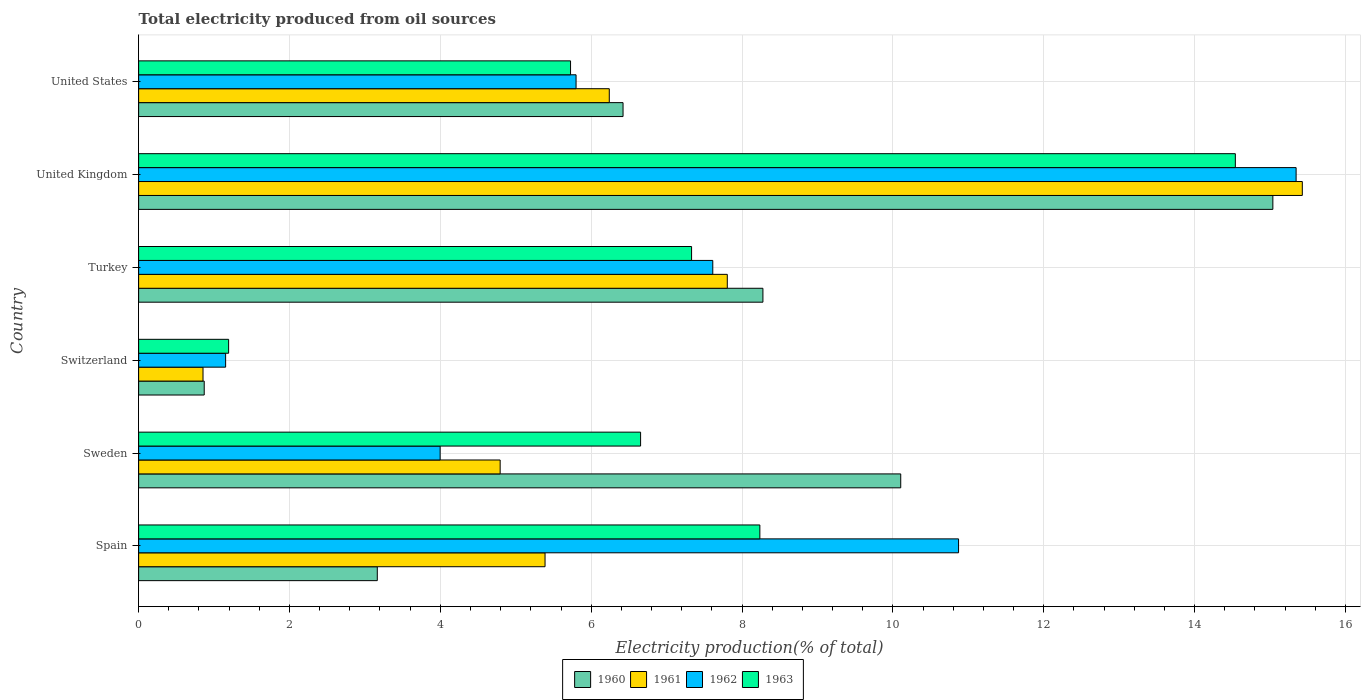How many different coloured bars are there?
Offer a very short reply. 4. Are the number of bars per tick equal to the number of legend labels?
Give a very brief answer. Yes. Are the number of bars on each tick of the Y-axis equal?
Ensure brevity in your answer.  Yes. How many bars are there on the 3rd tick from the top?
Give a very brief answer. 4. How many bars are there on the 5th tick from the bottom?
Make the answer very short. 4. What is the total electricity produced in 1962 in Spain?
Ensure brevity in your answer.  10.87. Across all countries, what is the maximum total electricity produced in 1960?
Provide a short and direct response. 15.04. Across all countries, what is the minimum total electricity produced in 1962?
Offer a very short reply. 1.15. In which country was the total electricity produced in 1962 minimum?
Offer a very short reply. Switzerland. What is the total total electricity produced in 1961 in the graph?
Provide a succinct answer. 40.51. What is the difference between the total electricity produced in 1963 in Turkey and that in United States?
Your response must be concise. 1.6. What is the difference between the total electricity produced in 1962 in Switzerland and the total electricity produced in 1963 in United States?
Keep it short and to the point. -4.57. What is the average total electricity produced in 1961 per country?
Ensure brevity in your answer.  6.75. What is the difference between the total electricity produced in 1963 and total electricity produced in 1962 in Spain?
Offer a terse response. -2.63. In how many countries, is the total electricity produced in 1960 greater than 15.2 %?
Provide a succinct answer. 0. What is the ratio of the total electricity produced in 1962 in Sweden to that in United States?
Provide a succinct answer. 0.69. Is the total electricity produced in 1960 in Turkey less than that in United States?
Provide a succinct answer. No. Is the difference between the total electricity produced in 1963 in Turkey and United States greater than the difference between the total electricity produced in 1962 in Turkey and United States?
Provide a short and direct response. No. What is the difference between the highest and the second highest total electricity produced in 1961?
Offer a terse response. 7.62. What is the difference between the highest and the lowest total electricity produced in 1961?
Provide a succinct answer. 14.57. Is the sum of the total electricity produced in 1963 in Turkey and United States greater than the maximum total electricity produced in 1961 across all countries?
Offer a terse response. No. Is it the case that in every country, the sum of the total electricity produced in 1961 and total electricity produced in 1960 is greater than the sum of total electricity produced in 1962 and total electricity produced in 1963?
Your answer should be compact. No. What does the 3rd bar from the top in Switzerland represents?
Your answer should be compact. 1961. What does the 4th bar from the bottom in Turkey represents?
Provide a short and direct response. 1963. How many bars are there?
Offer a terse response. 24. What is the difference between two consecutive major ticks on the X-axis?
Your answer should be compact. 2. Are the values on the major ticks of X-axis written in scientific E-notation?
Give a very brief answer. No. Does the graph contain any zero values?
Your answer should be compact. No. Where does the legend appear in the graph?
Provide a succinct answer. Bottom center. What is the title of the graph?
Give a very brief answer. Total electricity produced from oil sources. What is the Electricity production(% of total) of 1960 in Spain?
Make the answer very short. 3.16. What is the Electricity production(% of total) in 1961 in Spain?
Your answer should be compact. 5.39. What is the Electricity production(% of total) in 1962 in Spain?
Your answer should be very brief. 10.87. What is the Electricity production(% of total) in 1963 in Spain?
Your response must be concise. 8.24. What is the Electricity production(% of total) in 1960 in Sweden?
Your response must be concise. 10.1. What is the Electricity production(% of total) in 1961 in Sweden?
Provide a short and direct response. 4.79. What is the Electricity production(% of total) of 1962 in Sweden?
Your answer should be very brief. 4. What is the Electricity production(% of total) in 1963 in Sweden?
Your answer should be compact. 6.66. What is the Electricity production(% of total) of 1960 in Switzerland?
Make the answer very short. 0.87. What is the Electricity production(% of total) of 1961 in Switzerland?
Ensure brevity in your answer.  0.85. What is the Electricity production(% of total) of 1962 in Switzerland?
Ensure brevity in your answer.  1.15. What is the Electricity production(% of total) of 1963 in Switzerland?
Your response must be concise. 1.19. What is the Electricity production(% of total) in 1960 in Turkey?
Provide a succinct answer. 8.28. What is the Electricity production(% of total) in 1961 in Turkey?
Offer a very short reply. 7.8. What is the Electricity production(% of total) in 1962 in Turkey?
Your response must be concise. 7.61. What is the Electricity production(% of total) in 1963 in Turkey?
Provide a succinct answer. 7.33. What is the Electricity production(% of total) of 1960 in United Kingdom?
Provide a succinct answer. 15.04. What is the Electricity production(% of total) in 1961 in United Kingdom?
Your answer should be very brief. 15.43. What is the Electricity production(% of total) of 1962 in United Kingdom?
Provide a succinct answer. 15.35. What is the Electricity production(% of total) in 1963 in United Kingdom?
Provide a succinct answer. 14.54. What is the Electricity production(% of total) in 1960 in United States?
Provide a succinct answer. 6.42. What is the Electricity production(% of total) of 1961 in United States?
Give a very brief answer. 6.24. What is the Electricity production(% of total) in 1962 in United States?
Make the answer very short. 5.8. What is the Electricity production(% of total) of 1963 in United States?
Keep it short and to the point. 5.73. Across all countries, what is the maximum Electricity production(% of total) of 1960?
Give a very brief answer. 15.04. Across all countries, what is the maximum Electricity production(% of total) in 1961?
Offer a terse response. 15.43. Across all countries, what is the maximum Electricity production(% of total) in 1962?
Give a very brief answer. 15.35. Across all countries, what is the maximum Electricity production(% of total) in 1963?
Provide a succinct answer. 14.54. Across all countries, what is the minimum Electricity production(% of total) in 1960?
Ensure brevity in your answer.  0.87. Across all countries, what is the minimum Electricity production(% of total) in 1961?
Your response must be concise. 0.85. Across all countries, what is the minimum Electricity production(% of total) in 1962?
Give a very brief answer. 1.15. Across all countries, what is the minimum Electricity production(% of total) in 1963?
Ensure brevity in your answer.  1.19. What is the total Electricity production(% of total) of 1960 in the graph?
Ensure brevity in your answer.  43.88. What is the total Electricity production(% of total) of 1961 in the graph?
Ensure brevity in your answer.  40.51. What is the total Electricity production(% of total) of 1962 in the graph?
Your answer should be very brief. 44.78. What is the total Electricity production(% of total) of 1963 in the graph?
Provide a succinct answer. 43.68. What is the difference between the Electricity production(% of total) of 1960 in Spain and that in Sweden?
Your answer should be very brief. -6.94. What is the difference between the Electricity production(% of total) in 1961 in Spain and that in Sweden?
Ensure brevity in your answer.  0.6. What is the difference between the Electricity production(% of total) of 1962 in Spain and that in Sweden?
Offer a terse response. 6.87. What is the difference between the Electricity production(% of total) in 1963 in Spain and that in Sweden?
Keep it short and to the point. 1.58. What is the difference between the Electricity production(% of total) in 1960 in Spain and that in Switzerland?
Your response must be concise. 2.29. What is the difference between the Electricity production(% of total) in 1961 in Spain and that in Switzerland?
Give a very brief answer. 4.53. What is the difference between the Electricity production(% of total) in 1962 in Spain and that in Switzerland?
Give a very brief answer. 9.72. What is the difference between the Electricity production(% of total) of 1963 in Spain and that in Switzerland?
Your answer should be compact. 7.04. What is the difference between the Electricity production(% of total) of 1960 in Spain and that in Turkey?
Offer a terse response. -5.11. What is the difference between the Electricity production(% of total) of 1961 in Spain and that in Turkey?
Provide a succinct answer. -2.42. What is the difference between the Electricity production(% of total) of 1962 in Spain and that in Turkey?
Give a very brief answer. 3.26. What is the difference between the Electricity production(% of total) of 1963 in Spain and that in Turkey?
Make the answer very short. 0.91. What is the difference between the Electricity production(% of total) in 1960 in Spain and that in United Kingdom?
Give a very brief answer. -11.87. What is the difference between the Electricity production(% of total) in 1961 in Spain and that in United Kingdom?
Keep it short and to the point. -10.04. What is the difference between the Electricity production(% of total) in 1962 in Spain and that in United Kingdom?
Your response must be concise. -4.48. What is the difference between the Electricity production(% of total) of 1963 in Spain and that in United Kingdom?
Your answer should be very brief. -6.3. What is the difference between the Electricity production(% of total) of 1960 in Spain and that in United States?
Your answer should be very brief. -3.26. What is the difference between the Electricity production(% of total) in 1961 in Spain and that in United States?
Ensure brevity in your answer.  -0.85. What is the difference between the Electricity production(% of total) in 1962 in Spain and that in United States?
Offer a terse response. 5.07. What is the difference between the Electricity production(% of total) of 1963 in Spain and that in United States?
Provide a succinct answer. 2.51. What is the difference between the Electricity production(% of total) in 1960 in Sweden and that in Switzerland?
Your response must be concise. 9.23. What is the difference between the Electricity production(% of total) in 1961 in Sweden and that in Switzerland?
Keep it short and to the point. 3.94. What is the difference between the Electricity production(% of total) in 1962 in Sweden and that in Switzerland?
Your response must be concise. 2.84. What is the difference between the Electricity production(% of total) in 1963 in Sweden and that in Switzerland?
Provide a succinct answer. 5.46. What is the difference between the Electricity production(% of total) in 1960 in Sweden and that in Turkey?
Make the answer very short. 1.83. What is the difference between the Electricity production(% of total) in 1961 in Sweden and that in Turkey?
Give a very brief answer. -3.01. What is the difference between the Electricity production(% of total) in 1962 in Sweden and that in Turkey?
Ensure brevity in your answer.  -3.61. What is the difference between the Electricity production(% of total) of 1963 in Sweden and that in Turkey?
Give a very brief answer. -0.68. What is the difference between the Electricity production(% of total) of 1960 in Sweden and that in United Kingdom?
Your answer should be compact. -4.93. What is the difference between the Electricity production(% of total) of 1961 in Sweden and that in United Kingdom?
Offer a very short reply. -10.64. What is the difference between the Electricity production(% of total) in 1962 in Sweden and that in United Kingdom?
Give a very brief answer. -11.35. What is the difference between the Electricity production(% of total) in 1963 in Sweden and that in United Kingdom?
Make the answer very short. -7.89. What is the difference between the Electricity production(% of total) in 1960 in Sweden and that in United States?
Your answer should be compact. 3.68. What is the difference between the Electricity production(% of total) in 1961 in Sweden and that in United States?
Keep it short and to the point. -1.45. What is the difference between the Electricity production(% of total) in 1962 in Sweden and that in United States?
Your answer should be very brief. -1.8. What is the difference between the Electricity production(% of total) of 1963 in Sweden and that in United States?
Provide a short and direct response. 0.93. What is the difference between the Electricity production(% of total) of 1960 in Switzerland and that in Turkey?
Your answer should be compact. -7.41. What is the difference between the Electricity production(% of total) of 1961 in Switzerland and that in Turkey?
Offer a terse response. -6.95. What is the difference between the Electricity production(% of total) in 1962 in Switzerland and that in Turkey?
Your answer should be compact. -6.46. What is the difference between the Electricity production(% of total) in 1963 in Switzerland and that in Turkey?
Provide a succinct answer. -6.14. What is the difference between the Electricity production(% of total) in 1960 in Switzerland and that in United Kingdom?
Provide a short and direct response. -14.17. What is the difference between the Electricity production(% of total) of 1961 in Switzerland and that in United Kingdom?
Your answer should be very brief. -14.57. What is the difference between the Electricity production(% of total) in 1962 in Switzerland and that in United Kingdom?
Give a very brief answer. -14.19. What is the difference between the Electricity production(% of total) in 1963 in Switzerland and that in United Kingdom?
Offer a very short reply. -13.35. What is the difference between the Electricity production(% of total) in 1960 in Switzerland and that in United States?
Keep it short and to the point. -5.55. What is the difference between the Electricity production(% of total) in 1961 in Switzerland and that in United States?
Provide a succinct answer. -5.39. What is the difference between the Electricity production(% of total) of 1962 in Switzerland and that in United States?
Provide a succinct answer. -4.65. What is the difference between the Electricity production(% of total) in 1963 in Switzerland and that in United States?
Offer a terse response. -4.53. What is the difference between the Electricity production(% of total) of 1960 in Turkey and that in United Kingdom?
Offer a very short reply. -6.76. What is the difference between the Electricity production(% of total) of 1961 in Turkey and that in United Kingdom?
Your response must be concise. -7.62. What is the difference between the Electricity production(% of total) of 1962 in Turkey and that in United Kingdom?
Provide a succinct answer. -7.73. What is the difference between the Electricity production(% of total) of 1963 in Turkey and that in United Kingdom?
Give a very brief answer. -7.21. What is the difference between the Electricity production(% of total) in 1960 in Turkey and that in United States?
Provide a succinct answer. 1.85. What is the difference between the Electricity production(% of total) of 1961 in Turkey and that in United States?
Your answer should be compact. 1.56. What is the difference between the Electricity production(% of total) of 1962 in Turkey and that in United States?
Provide a succinct answer. 1.81. What is the difference between the Electricity production(% of total) in 1963 in Turkey and that in United States?
Make the answer very short. 1.6. What is the difference between the Electricity production(% of total) in 1960 in United Kingdom and that in United States?
Keep it short and to the point. 8.62. What is the difference between the Electricity production(% of total) of 1961 in United Kingdom and that in United States?
Your answer should be compact. 9.19. What is the difference between the Electricity production(% of total) of 1962 in United Kingdom and that in United States?
Offer a very short reply. 9.55. What is the difference between the Electricity production(% of total) of 1963 in United Kingdom and that in United States?
Your answer should be compact. 8.81. What is the difference between the Electricity production(% of total) in 1960 in Spain and the Electricity production(% of total) in 1961 in Sweden?
Offer a terse response. -1.63. What is the difference between the Electricity production(% of total) in 1960 in Spain and the Electricity production(% of total) in 1963 in Sweden?
Give a very brief answer. -3.49. What is the difference between the Electricity production(% of total) of 1961 in Spain and the Electricity production(% of total) of 1962 in Sweden?
Offer a very short reply. 1.39. What is the difference between the Electricity production(% of total) of 1961 in Spain and the Electricity production(% of total) of 1963 in Sweden?
Give a very brief answer. -1.27. What is the difference between the Electricity production(% of total) of 1962 in Spain and the Electricity production(% of total) of 1963 in Sweden?
Give a very brief answer. 4.22. What is the difference between the Electricity production(% of total) of 1960 in Spain and the Electricity production(% of total) of 1961 in Switzerland?
Your response must be concise. 2.31. What is the difference between the Electricity production(% of total) in 1960 in Spain and the Electricity production(% of total) in 1962 in Switzerland?
Offer a terse response. 2.01. What is the difference between the Electricity production(% of total) in 1960 in Spain and the Electricity production(% of total) in 1963 in Switzerland?
Your response must be concise. 1.97. What is the difference between the Electricity production(% of total) in 1961 in Spain and the Electricity production(% of total) in 1962 in Switzerland?
Offer a terse response. 4.24. What is the difference between the Electricity production(% of total) of 1961 in Spain and the Electricity production(% of total) of 1963 in Switzerland?
Keep it short and to the point. 4.2. What is the difference between the Electricity production(% of total) in 1962 in Spain and the Electricity production(% of total) in 1963 in Switzerland?
Offer a very short reply. 9.68. What is the difference between the Electricity production(% of total) of 1960 in Spain and the Electricity production(% of total) of 1961 in Turkey?
Provide a short and direct response. -4.64. What is the difference between the Electricity production(% of total) of 1960 in Spain and the Electricity production(% of total) of 1962 in Turkey?
Give a very brief answer. -4.45. What is the difference between the Electricity production(% of total) in 1960 in Spain and the Electricity production(% of total) in 1963 in Turkey?
Keep it short and to the point. -4.17. What is the difference between the Electricity production(% of total) of 1961 in Spain and the Electricity production(% of total) of 1962 in Turkey?
Provide a short and direct response. -2.22. What is the difference between the Electricity production(% of total) in 1961 in Spain and the Electricity production(% of total) in 1963 in Turkey?
Your answer should be very brief. -1.94. What is the difference between the Electricity production(% of total) in 1962 in Spain and the Electricity production(% of total) in 1963 in Turkey?
Provide a succinct answer. 3.54. What is the difference between the Electricity production(% of total) of 1960 in Spain and the Electricity production(% of total) of 1961 in United Kingdom?
Keep it short and to the point. -12.26. What is the difference between the Electricity production(% of total) of 1960 in Spain and the Electricity production(% of total) of 1962 in United Kingdom?
Your answer should be very brief. -12.18. What is the difference between the Electricity production(% of total) of 1960 in Spain and the Electricity production(% of total) of 1963 in United Kingdom?
Offer a terse response. -11.38. What is the difference between the Electricity production(% of total) of 1961 in Spain and the Electricity production(% of total) of 1962 in United Kingdom?
Provide a short and direct response. -9.96. What is the difference between the Electricity production(% of total) in 1961 in Spain and the Electricity production(% of total) in 1963 in United Kingdom?
Ensure brevity in your answer.  -9.15. What is the difference between the Electricity production(% of total) in 1962 in Spain and the Electricity production(% of total) in 1963 in United Kingdom?
Provide a short and direct response. -3.67. What is the difference between the Electricity production(% of total) in 1960 in Spain and the Electricity production(% of total) in 1961 in United States?
Your response must be concise. -3.08. What is the difference between the Electricity production(% of total) of 1960 in Spain and the Electricity production(% of total) of 1962 in United States?
Your answer should be compact. -2.64. What is the difference between the Electricity production(% of total) in 1960 in Spain and the Electricity production(% of total) in 1963 in United States?
Give a very brief answer. -2.56. What is the difference between the Electricity production(% of total) of 1961 in Spain and the Electricity production(% of total) of 1962 in United States?
Your answer should be compact. -0.41. What is the difference between the Electricity production(% of total) of 1961 in Spain and the Electricity production(% of total) of 1963 in United States?
Your response must be concise. -0.34. What is the difference between the Electricity production(% of total) of 1962 in Spain and the Electricity production(% of total) of 1963 in United States?
Ensure brevity in your answer.  5.14. What is the difference between the Electricity production(% of total) in 1960 in Sweden and the Electricity production(% of total) in 1961 in Switzerland?
Provide a succinct answer. 9.25. What is the difference between the Electricity production(% of total) in 1960 in Sweden and the Electricity production(% of total) in 1962 in Switzerland?
Offer a very short reply. 8.95. What is the difference between the Electricity production(% of total) in 1960 in Sweden and the Electricity production(% of total) in 1963 in Switzerland?
Keep it short and to the point. 8.91. What is the difference between the Electricity production(% of total) of 1961 in Sweden and the Electricity production(% of total) of 1962 in Switzerland?
Your response must be concise. 3.64. What is the difference between the Electricity production(% of total) of 1962 in Sweden and the Electricity production(% of total) of 1963 in Switzerland?
Provide a short and direct response. 2.8. What is the difference between the Electricity production(% of total) in 1960 in Sweden and the Electricity production(% of total) in 1961 in Turkey?
Your response must be concise. 2.3. What is the difference between the Electricity production(% of total) of 1960 in Sweden and the Electricity production(% of total) of 1962 in Turkey?
Your answer should be very brief. 2.49. What is the difference between the Electricity production(% of total) of 1960 in Sweden and the Electricity production(% of total) of 1963 in Turkey?
Your answer should be very brief. 2.77. What is the difference between the Electricity production(% of total) in 1961 in Sweden and the Electricity production(% of total) in 1962 in Turkey?
Keep it short and to the point. -2.82. What is the difference between the Electricity production(% of total) of 1961 in Sweden and the Electricity production(% of total) of 1963 in Turkey?
Provide a succinct answer. -2.54. What is the difference between the Electricity production(% of total) in 1962 in Sweden and the Electricity production(% of total) in 1963 in Turkey?
Your response must be concise. -3.33. What is the difference between the Electricity production(% of total) in 1960 in Sweden and the Electricity production(% of total) in 1961 in United Kingdom?
Offer a very short reply. -5.32. What is the difference between the Electricity production(% of total) of 1960 in Sweden and the Electricity production(% of total) of 1962 in United Kingdom?
Offer a very short reply. -5.24. What is the difference between the Electricity production(% of total) in 1960 in Sweden and the Electricity production(% of total) in 1963 in United Kingdom?
Provide a short and direct response. -4.44. What is the difference between the Electricity production(% of total) in 1961 in Sweden and the Electricity production(% of total) in 1962 in United Kingdom?
Keep it short and to the point. -10.55. What is the difference between the Electricity production(% of total) of 1961 in Sweden and the Electricity production(% of total) of 1963 in United Kingdom?
Keep it short and to the point. -9.75. What is the difference between the Electricity production(% of total) in 1962 in Sweden and the Electricity production(% of total) in 1963 in United Kingdom?
Your answer should be very brief. -10.54. What is the difference between the Electricity production(% of total) in 1960 in Sweden and the Electricity production(% of total) in 1961 in United States?
Offer a terse response. 3.86. What is the difference between the Electricity production(% of total) in 1960 in Sweden and the Electricity production(% of total) in 1962 in United States?
Make the answer very short. 4.3. What is the difference between the Electricity production(% of total) of 1960 in Sweden and the Electricity production(% of total) of 1963 in United States?
Your answer should be very brief. 4.38. What is the difference between the Electricity production(% of total) of 1961 in Sweden and the Electricity production(% of total) of 1962 in United States?
Make the answer very short. -1.01. What is the difference between the Electricity production(% of total) in 1961 in Sweden and the Electricity production(% of total) in 1963 in United States?
Provide a short and direct response. -0.93. What is the difference between the Electricity production(% of total) of 1962 in Sweden and the Electricity production(% of total) of 1963 in United States?
Make the answer very short. -1.73. What is the difference between the Electricity production(% of total) in 1960 in Switzerland and the Electricity production(% of total) in 1961 in Turkey?
Your response must be concise. -6.94. What is the difference between the Electricity production(% of total) in 1960 in Switzerland and the Electricity production(% of total) in 1962 in Turkey?
Ensure brevity in your answer.  -6.74. What is the difference between the Electricity production(% of total) in 1960 in Switzerland and the Electricity production(% of total) in 1963 in Turkey?
Ensure brevity in your answer.  -6.46. What is the difference between the Electricity production(% of total) in 1961 in Switzerland and the Electricity production(% of total) in 1962 in Turkey?
Your response must be concise. -6.76. What is the difference between the Electricity production(% of total) in 1961 in Switzerland and the Electricity production(% of total) in 1963 in Turkey?
Ensure brevity in your answer.  -6.48. What is the difference between the Electricity production(% of total) of 1962 in Switzerland and the Electricity production(% of total) of 1963 in Turkey?
Your answer should be compact. -6.18. What is the difference between the Electricity production(% of total) in 1960 in Switzerland and the Electricity production(% of total) in 1961 in United Kingdom?
Your answer should be compact. -14.56. What is the difference between the Electricity production(% of total) of 1960 in Switzerland and the Electricity production(% of total) of 1962 in United Kingdom?
Provide a short and direct response. -14.48. What is the difference between the Electricity production(% of total) of 1960 in Switzerland and the Electricity production(% of total) of 1963 in United Kingdom?
Your answer should be very brief. -13.67. What is the difference between the Electricity production(% of total) of 1961 in Switzerland and the Electricity production(% of total) of 1962 in United Kingdom?
Offer a terse response. -14.49. What is the difference between the Electricity production(% of total) of 1961 in Switzerland and the Electricity production(% of total) of 1963 in United Kingdom?
Your answer should be very brief. -13.69. What is the difference between the Electricity production(% of total) in 1962 in Switzerland and the Electricity production(% of total) in 1963 in United Kingdom?
Provide a succinct answer. -13.39. What is the difference between the Electricity production(% of total) of 1960 in Switzerland and the Electricity production(% of total) of 1961 in United States?
Your answer should be compact. -5.37. What is the difference between the Electricity production(% of total) of 1960 in Switzerland and the Electricity production(% of total) of 1962 in United States?
Ensure brevity in your answer.  -4.93. What is the difference between the Electricity production(% of total) of 1960 in Switzerland and the Electricity production(% of total) of 1963 in United States?
Provide a short and direct response. -4.86. What is the difference between the Electricity production(% of total) of 1961 in Switzerland and the Electricity production(% of total) of 1962 in United States?
Provide a short and direct response. -4.95. What is the difference between the Electricity production(% of total) in 1961 in Switzerland and the Electricity production(% of total) in 1963 in United States?
Ensure brevity in your answer.  -4.87. What is the difference between the Electricity production(% of total) of 1962 in Switzerland and the Electricity production(% of total) of 1963 in United States?
Ensure brevity in your answer.  -4.57. What is the difference between the Electricity production(% of total) in 1960 in Turkey and the Electricity production(% of total) in 1961 in United Kingdom?
Your response must be concise. -7.15. What is the difference between the Electricity production(% of total) of 1960 in Turkey and the Electricity production(% of total) of 1962 in United Kingdom?
Provide a succinct answer. -7.07. What is the difference between the Electricity production(% of total) of 1960 in Turkey and the Electricity production(% of total) of 1963 in United Kingdom?
Offer a terse response. -6.26. What is the difference between the Electricity production(% of total) of 1961 in Turkey and the Electricity production(% of total) of 1962 in United Kingdom?
Your response must be concise. -7.54. What is the difference between the Electricity production(% of total) of 1961 in Turkey and the Electricity production(% of total) of 1963 in United Kingdom?
Provide a short and direct response. -6.74. What is the difference between the Electricity production(% of total) in 1962 in Turkey and the Electricity production(% of total) in 1963 in United Kingdom?
Give a very brief answer. -6.93. What is the difference between the Electricity production(% of total) in 1960 in Turkey and the Electricity production(% of total) in 1961 in United States?
Give a very brief answer. 2.04. What is the difference between the Electricity production(% of total) in 1960 in Turkey and the Electricity production(% of total) in 1962 in United States?
Keep it short and to the point. 2.48. What is the difference between the Electricity production(% of total) in 1960 in Turkey and the Electricity production(% of total) in 1963 in United States?
Your response must be concise. 2.55. What is the difference between the Electricity production(% of total) of 1961 in Turkey and the Electricity production(% of total) of 1962 in United States?
Your response must be concise. 2.01. What is the difference between the Electricity production(% of total) in 1961 in Turkey and the Electricity production(% of total) in 1963 in United States?
Make the answer very short. 2.08. What is the difference between the Electricity production(% of total) in 1962 in Turkey and the Electricity production(% of total) in 1963 in United States?
Offer a terse response. 1.89. What is the difference between the Electricity production(% of total) of 1960 in United Kingdom and the Electricity production(% of total) of 1961 in United States?
Provide a succinct answer. 8.8. What is the difference between the Electricity production(% of total) of 1960 in United Kingdom and the Electricity production(% of total) of 1962 in United States?
Provide a succinct answer. 9.24. What is the difference between the Electricity production(% of total) in 1960 in United Kingdom and the Electricity production(% of total) in 1963 in United States?
Your answer should be very brief. 9.31. What is the difference between the Electricity production(% of total) in 1961 in United Kingdom and the Electricity production(% of total) in 1962 in United States?
Give a very brief answer. 9.63. What is the difference between the Electricity production(% of total) in 1961 in United Kingdom and the Electricity production(% of total) in 1963 in United States?
Make the answer very short. 9.7. What is the difference between the Electricity production(% of total) of 1962 in United Kingdom and the Electricity production(% of total) of 1963 in United States?
Keep it short and to the point. 9.62. What is the average Electricity production(% of total) of 1960 per country?
Your answer should be compact. 7.31. What is the average Electricity production(% of total) of 1961 per country?
Provide a short and direct response. 6.75. What is the average Electricity production(% of total) of 1962 per country?
Provide a short and direct response. 7.46. What is the average Electricity production(% of total) in 1963 per country?
Ensure brevity in your answer.  7.28. What is the difference between the Electricity production(% of total) in 1960 and Electricity production(% of total) in 1961 in Spain?
Offer a very short reply. -2.22. What is the difference between the Electricity production(% of total) of 1960 and Electricity production(% of total) of 1962 in Spain?
Provide a succinct answer. -7.71. What is the difference between the Electricity production(% of total) of 1960 and Electricity production(% of total) of 1963 in Spain?
Offer a very short reply. -5.07. What is the difference between the Electricity production(% of total) in 1961 and Electricity production(% of total) in 1962 in Spain?
Your response must be concise. -5.48. What is the difference between the Electricity production(% of total) of 1961 and Electricity production(% of total) of 1963 in Spain?
Make the answer very short. -2.85. What is the difference between the Electricity production(% of total) in 1962 and Electricity production(% of total) in 1963 in Spain?
Make the answer very short. 2.63. What is the difference between the Electricity production(% of total) of 1960 and Electricity production(% of total) of 1961 in Sweden?
Your answer should be very brief. 5.31. What is the difference between the Electricity production(% of total) in 1960 and Electricity production(% of total) in 1962 in Sweden?
Provide a succinct answer. 6.11. What is the difference between the Electricity production(% of total) in 1960 and Electricity production(% of total) in 1963 in Sweden?
Keep it short and to the point. 3.45. What is the difference between the Electricity production(% of total) in 1961 and Electricity production(% of total) in 1962 in Sweden?
Make the answer very short. 0.8. What is the difference between the Electricity production(% of total) in 1961 and Electricity production(% of total) in 1963 in Sweden?
Keep it short and to the point. -1.86. What is the difference between the Electricity production(% of total) in 1962 and Electricity production(% of total) in 1963 in Sweden?
Your answer should be very brief. -2.66. What is the difference between the Electricity production(% of total) of 1960 and Electricity production(% of total) of 1961 in Switzerland?
Give a very brief answer. 0.02. What is the difference between the Electricity production(% of total) of 1960 and Electricity production(% of total) of 1962 in Switzerland?
Offer a very short reply. -0.28. What is the difference between the Electricity production(% of total) of 1960 and Electricity production(% of total) of 1963 in Switzerland?
Your response must be concise. -0.32. What is the difference between the Electricity production(% of total) of 1961 and Electricity production(% of total) of 1962 in Switzerland?
Provide a short and direct response. -0.3. What is the difference between the Electricity production(% of total) in 1961 and Electricity production(% of total) in 1963 in Switzerland?
Ensure brevity in your answer.  -0.34. What is the difference between the Electricity production(% of total) in 1962 and Electricity production(% of total) in 1963 in Switzerland?
Your answer should be compact. -0.04. What is the difference between the Electricity production(% of total) in 1960 and Electricity production(% of total) in 1961 in Turkey?
Offer a terse response. 0.47. What is the difference between the Electricity production(% of total) in 1960 and Electricity production(% of total) in 1962 in Turkey?
Your answer should be very brief. 0.66. What is the difference between the Electricity production(% of total) of 1960 and Electricity production(% of total) of 1963 in Turkey?
Your answer should be very brief. 0.95. What is the difference between the Electricity production(% of total) of 1961 and Electricity production(% of total) of 1962 in Turkey?
Your answer should be very brief. 0.19. What is the difference between the Electricity production(% of total) in 1961 and Electricity production(% of total) in 1963 in Turkey?
Offer a very short reply. 0.47. What is the difference between the Electricity production(% of total) of 1962 and Electricity production(% of total) of 1963 in Turkey?
Your answer should be very brief. 0.28. What is the difference between the Electricity production(% of total) of 1960 and Electricity production(% of total) of 1961 in United Kingdom?
Make the answer very short. -0.39. What is the difference between the Electricity production(% of total) of 1960 and Electricity production(% of total) of 1962 in United Kingdom?
Provide a succinct answer. -0.31. What is the difference between the Electricity production(% of total) of 1960 and Electricity production(% of total) of 1963 in United Kingdom?
Offer a very short reply. 0.5. What is the difference between the Electricity production(% of total) in 1961 and Electricity production(% of total) in 1962 in United Kingdom?
Your answer should be very brief. 0.08. What is the difference between the Electricity production(% of total) of 1961 and Electricity production(% of total) of 1963 in United Kingdom?
Make the answer very short. 0.89. What is the difference between the Electricity production(% of total) of 1962 and Electricity production(% of total) of 1963 in United Kingdom?
Your answer should be compact. 0.81. What is the difference between the Electricity production(% of total) of 1960 and Electricity production(% of total) of 1961 in United States?
Ensure brevity in your answer.  0.18. What is the difference between the Electricity production(% of total) in 1960 and Electricity production(% of total) in 1962 in United States?
Offer a terse response. 0.62. What is the difference between the Electricity production(% of total) of 1960 and Electricity production(% of total) of 1963 in United States?
Your answer should be compact. 0.7. What is the difference between the Electricity production(% of total) of 1961 and Electricity production(% of total) of 1962 in United States?
Your answer should be very brief. 0.44. What is the difference between the Electricity production(% of total) in 1961 and Electricity production(% of total) in 1963 in United States?
Make the answer very short. 0.51. What is the difference between the Electricity production(% of total) of 1962 and Electricity production(% of total) of 1963 in United States?
Your response must be concise. 0.07. What is the ratio of the Electricity production(% of total) of 1960 in Spain to that in Sweden?
Keep it short and to the point. 0.31. What is the ratio of the Electricity production(% of total) of 1961 in Spain to that in Sweden?
Give a very brief answer. 1.12. What is the ratio of the Electricity production(% of total) in 1962 in Spain to that in Sweden?
Give a very brief answer. 2.72. What is the ratio of the Electricity production(% of total) of 1963 in Spain to that in Sweden?
Keep it short and to the point. 1.24. What is the ratio of the Electricity production(% of total) of 1960 in Spain to that in Switzerland?
Provide a succinct answer. 3.64. What is the ratio of the Electricity production(% of total) in 1961 in Spain to that in Switzerland?
Give a very brief answer. 6.31. What is the ratio of the Electricity production(% of total) in 1962 in Spain to that in Switzerland?
Make the answer very short. 9.43. What is the ratio of the Electricity production(% of total) of 1963 in Spain to that in Switzerland?
Your response must be concise. 6.9. What is the ratio of the Electricity production(% of total) of 1960 in Spain to that in Turkey?
Provide a short and direct response. 0.38. What is the ratio of the Electricity production(% of total) in 1961 in Spain to that in Turkey?
Keep it short and to the point. 0.69. What is the ratio of the Electricity production(% of total) of 1962 in Spain to that in Turkey?
Your answer should be compact. 1.43. What is the ratio of the Electricity production(% of total) of 1963 in Spain to that in Turkey?
Ensure brevity in your answer.  1.12. What is the ratio of the Electricity production(% of total) of 1960 in Spain to that in United Kingdom?
Give a very brief answer. 0.21. What is the ratio of the Electricity production(% of total) in 1961 in Spain to that in United Kingdom?
Give a very brief answer. 0.35. What is the ratio of the Electricity production(% of total) in 1962 in Spain to that in United Kingdom?
Your answer should be very brief. 0.71. What is the ratio of the Electricity production(% of total) of 1963 in Spain to that in United Kingdom?
Offer a very short reply. 0.57. What is the ratio of the Electricity production(% of total) in 1960 in Spain to that in United States?
Provide a succinct answer. 0.49. What is the ratio of the Electricity production(% of total) of 1961 in Spain to that in United States?
Ensure brevity in your answer.  0.86. What is the ratio of the Electricity production(% of total) of 1962 in Spain to that in United States?
Your response must be concise. 1.87. What is the ratio of the Electricity production(% of total) in 1963 in Spain to that in United States?
Give a very brief answer. 1.44. What is the ratio of the Electricity production(% of total) of 1960 in Sweden to that in Switzerland?
Offer a terse response. 11.62. What is the ratio of the Electricity production(% of total) in 1961 in Sweden to that in Switzerland?
Ensure brevity in your answer.  5.62. What is the ratio of the Electricity production(% of total) in 1962 in Sweden to that in Switzerland?
Make the answer very short. 3.47. What is the ratio of the Electricity production(% of total) of 1963 in Sweden to that in Switzerland?
Provide a succinct answer. 5.58. What is the ratio of the Electricity production(% of total) of 1960 in Sweden to that in Turkey?
Ensure brevity in your answer.  1.22. What is the ratio of the Electricity production(% of total) of 1961 in Sweden to that in Turkey?
Provide a succinct answer. 0.61. What is the ratio of the Electricity production(% of total) in 1962 in Sweden to that in Turkey?
Ensure brevity in your answer.  0.53. What is the ratio of the Electricity production(% of total) of 1963 in Sweden to that in Turkey?
Make the answer very short. 0.91. What is the ratio of the Electricity production(% of total) in 1960 in Sweden to that in United Kingdom?
Ensure brevity in your answer.  0.67. What is the ratio of the Electricity production(% of total) of 1961 in Sweden to that in United Kingdom?
Keep it short and to the point. 0.31. What is the ratio of the Electricity production(% of total) of 1962 in Sweden to that in United Kingdom?
Your response must be concise. 0.26. What is the ratio of the Electricity production(% of total) of 1963 in Sweden to that in United Kingdom?
Provide a succinct answer. 0.46. What is the ratio of the Electricity production(% of total) in 1960 in Sweden to that in United States?
Offer a terse response. 1.57. What is the ratio of the Electricity production(% of total) of 1961 in Sweden to that in United States?
Your answer should be very brief. 0.77. What is the ratio of the Electricity production(% of total) in 1962 in Sweden to that in United States?
Offer a very short reply. 0.69. What is the ratio of the Electricity production(% of total) in 1963 in Sweden to that in United States?
Make the answer very short. 1.16. What is the ratio of the Electricity production(% of total) of 1960 in Switzerland to that in Turkey?
Your answer should be very brief. 0.11. What is the ratio of the Electricity production(% of total) in 1961 in Switzerland to that in Turkey?
Your response must be concise. 0.11. What is the ratio of the Electricity production(% of total) of 1962 in Switzerland to that in Turkey?
Make the answer very short. 0.15. What is the ratio of the Electricity production(% of total) in 1963 in Switzerland to that in Turkey?
Ensure brevity in your answer.  0.16. What is the ratio of the Electricity production(% of total) in 1960 in Switzerland to that in United Kingdom?
Give a very brief answer. 0.06. What is the ratio of the Electricity production(% of total) in 1961 in Switzerland to that in United Kingdom?
Your response must be concise. 0.06. What is the ratio of the Electricity production(% of total) of 1962 in Switzerland to that in United Kingdom?
Offer a terse response. 0.08. What is the ratio of the Electricity production(% of total) in 1963 in Switzerland to that in United Kingdom?
Your response must be concise. 0.08. What is the ratio of the Electricity production(% of total) in 1960 in Switzerland to that in United States?
Your response must be concise. 0.14. What is the ratio of the Electricity production(% of total) of 1961 in Switzerland to that in United States?
Your answer should be compact. 0.14. What is the ratio of the Electricity production(% of total) in 1962 in Switzerland to that in United States?
Offer a very short reply. 0.2. What is the ratio of the Electricity production(% of total) in 1963 in Switzerland to that in United States?
Offer a terse response. 0.21. What is the ratio of the Electricity production(% of total) of 1960 in Turkey to that in United Kingdom?
Your answer should be very brief. 0.55. What is the ratio of the Electricity production(% of total) of 1961 in Turkey to that in United Kingdom?
Your response must be concise. 0.51. What is the ratio of the Electricity production(% of total) of 1962 in Turkey to that in United Kingdom?
Your answer should be very brief. 0.5. What is the ratio of the Electricity production(% of total) of 1963 in Turkey to that in United Kingdom?
Your answer should be compact. 0.5. What is the ratio of the Electricity production(% of total) in 1960 in Turkey to that in United States?
Offer a terse response. 1.29. What is the ratio of the Electricity production(% of total) in 1961 in Turkey to that in United States?
Offer a terse response. 1.25. What is the ratio of the Electricity production(% of total) in 1962 in Turkey to that in United States?
Offer a very short reply. 1.31. What is the ratio of the Electricity production(% of total) in 1963 in Turkey to that in United States?
Offer a very short reply. 1.28. What is the ratio of the Electricity production(% of total) of 1960 in United Kingdom to that in United States?
Your response must be concise. 2.34. What is the ratio of the Electricity production(% of total) of 1961 in United Kingdom to that in United States?
Your response must be concise. 2.47. What is the ratio of the Electricity production(% of total) in 1962 in United Kingdom to that in United States?
Make the answer very short. 2.65. What is the ratio of the Electricity production(% of total) in 1963 in United Kingdom to that in United States?
Keep it short and to the point. 2.54. What is the difference between the highest and the second highest Electricity production(% of total) of 1960?
Offer a terse response. 4.93. What is the difference between the highest and the second highest Electricity production(% of total) of 1961?
Keep it short and to the point. 7.62. What is the difference between the highest and the second highest Electricity production(% of total) of 1962?
Ensure brevity in your answer.  4.48. What is the difference between the highest and the second highest Electricity production(% of total) in 1963?
Your response must be concise. 6.3. What is the difference between the highest and the lowest Electricity production(% of total) in 1960?
Make the answer very short. 14.17. What is the difference between the highest and the lowest Electricity production(% of total) in 1961?
Your answer should be compact. 14.57. What is the difference between the highest and the lowest Electricity production(% of total) of 1962?
Offer a terse response. 14.19. What is the difference between the highest and the lowest Electricity production(% of total) of 1963?
Make the answer very short. 13.35. 